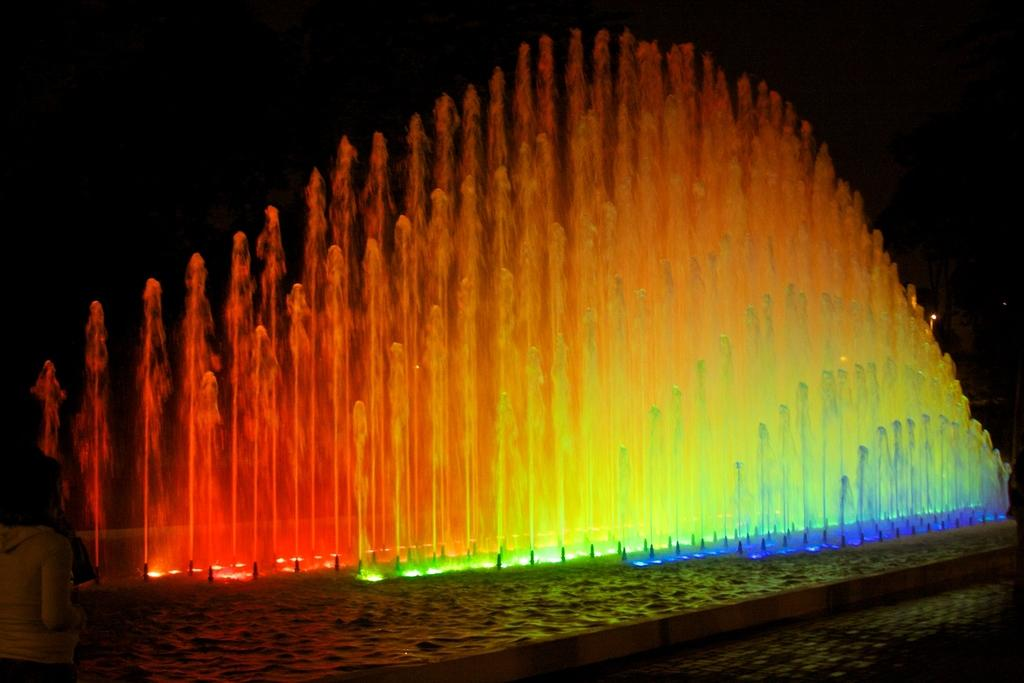What type of fountains are present in the image? There are water fountains with lights in the image. Can you describe the person in the image? There is a person on the left side of the image. What type of rat can be seen interacting with the water fountains in the image? There is no rat present in the image; it features water fountains with lights and a person. What type of lock is securing the water fountains in the image? There is no lock present in the image; the water fountains are not secured by a lock. 